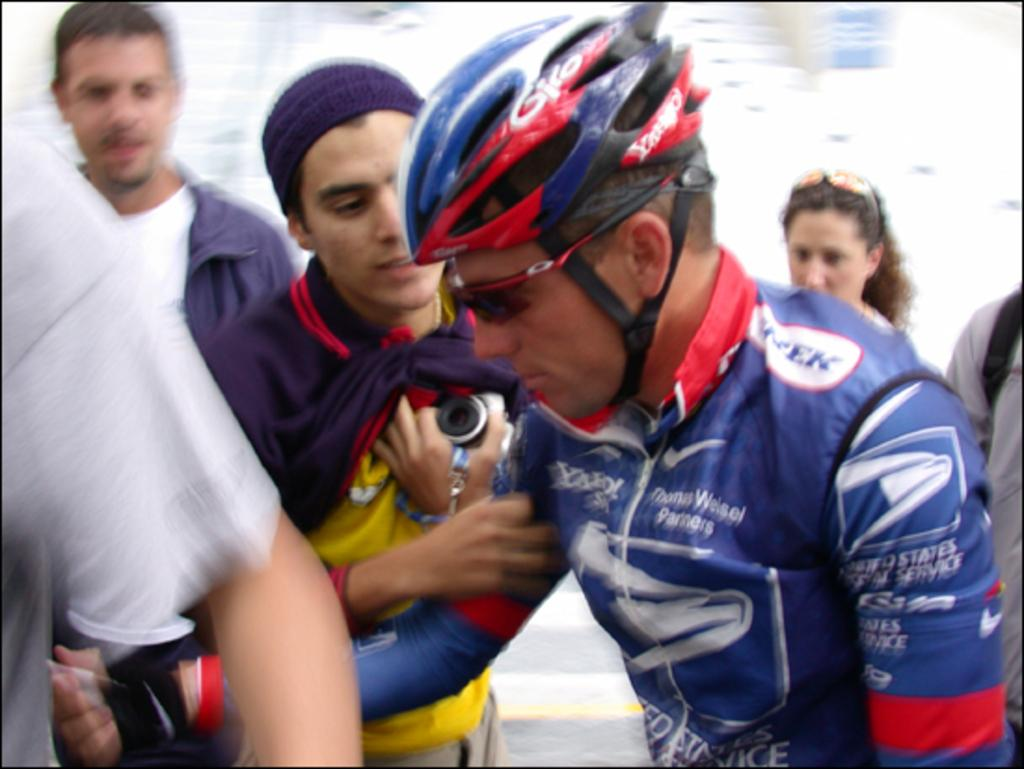What is the person in the image wearing on their head? The person in the image is wearing a helmet. What type of eyewear is the person wearing? The person is wearing spectacles. How many people are present in the image? There is a group of people standing in the image. Can you describe the background of the image? The background of the image is blurred. What type of notebook is the person holding in the image? There is no notebook present in the image. What type of trees can be seen in the background of the image? The background of the image is blurred, so it is not possible to identify any trees. 